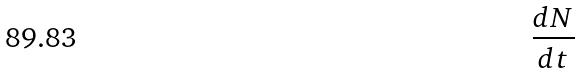Convert formula to latex. <formula><loc_0><loc_0><loc_500><loc_500>\frac { d N } { d t }</formula> 